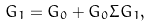Convert formula to latex. <formula><loc_0><loc_0><loc_500><loc_500>G _ { 1 } = G _ { 0 } + G _ { 0 } \Sigma G _ { 1 } ,</formula> 